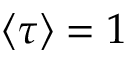Convert formula to latex. <formula><loc_0><loc_0><loc_500><loc_500>\langle \tau \rangle = 1</formula> 